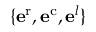<formula> <loc_0><loc_0><loc_500><loc_500>\{ e ^ { r } , e ^ { c } , e ^ { l } \}</formula> 